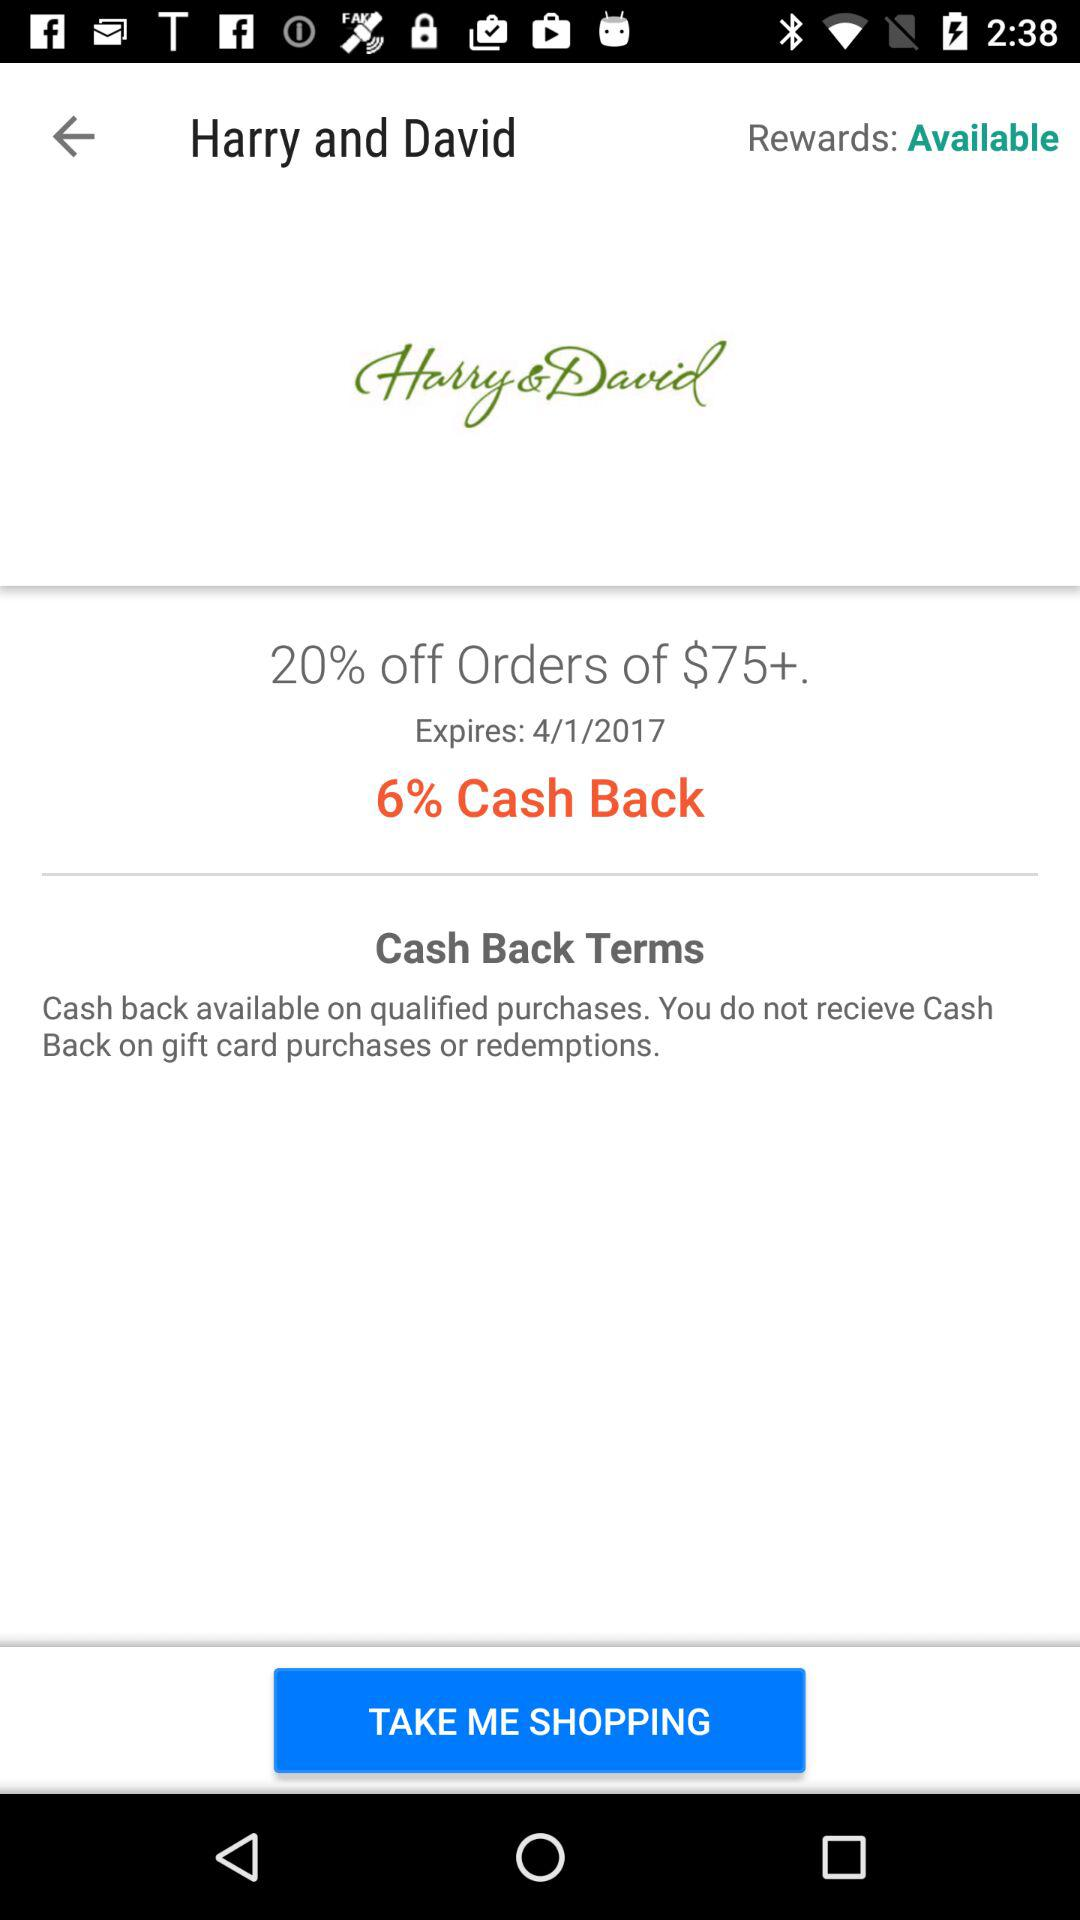How much do I need to spend to get the discount?
Answer the question using a single word or phrase. $75+ 